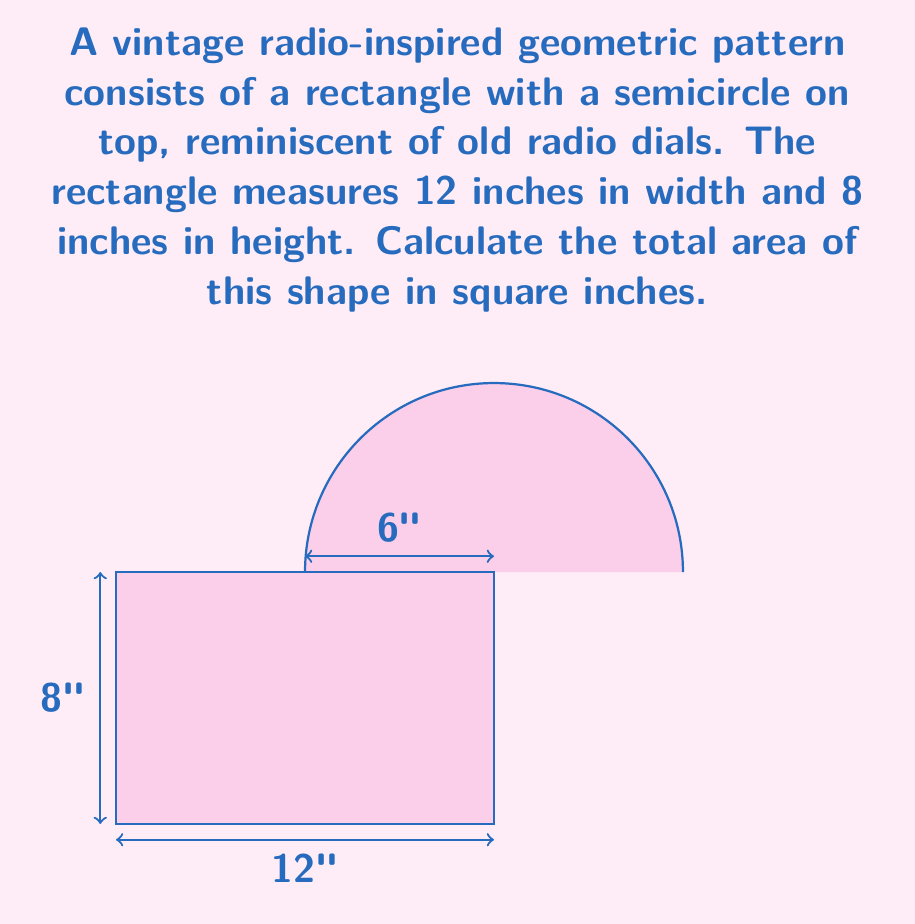Provide a solution to this math problem. To calculate the total area, we need to sum the areas of the rectangle and the semicircle:

1. Area of the rectangle:
   $A_r = w \times h = 12 \text{ in} \times 8 \text{ in} = 96 \text{ in}^2$

2. Area of the semicircle:
   - The radius of the semicircle is half the width of the rectangle: $r = 12 \text{ in} \div 2 = 6 \text{ in}$
   - Area of a full circle: $A_c = \pi r^2$
   - Area of semicircle: $A_s = \frac{1}{2} \pi r^2$
   
   $A_s = \frac{1}{2} \pi (6 \text{ in})^2 = 18\pi \text{ in}^2$

3. Total area:
   $A_{\text{total}} = A_r + A_s = 96 \text{ in}^2 + 18\pi \text{ in}^2$

   $A_{\text{total}} = 96 + 18\pi \text{ in}^2 \approx 152.57 \text{ in}^2$
Answer: $96 + 18\pi \text{ in}^2$ 